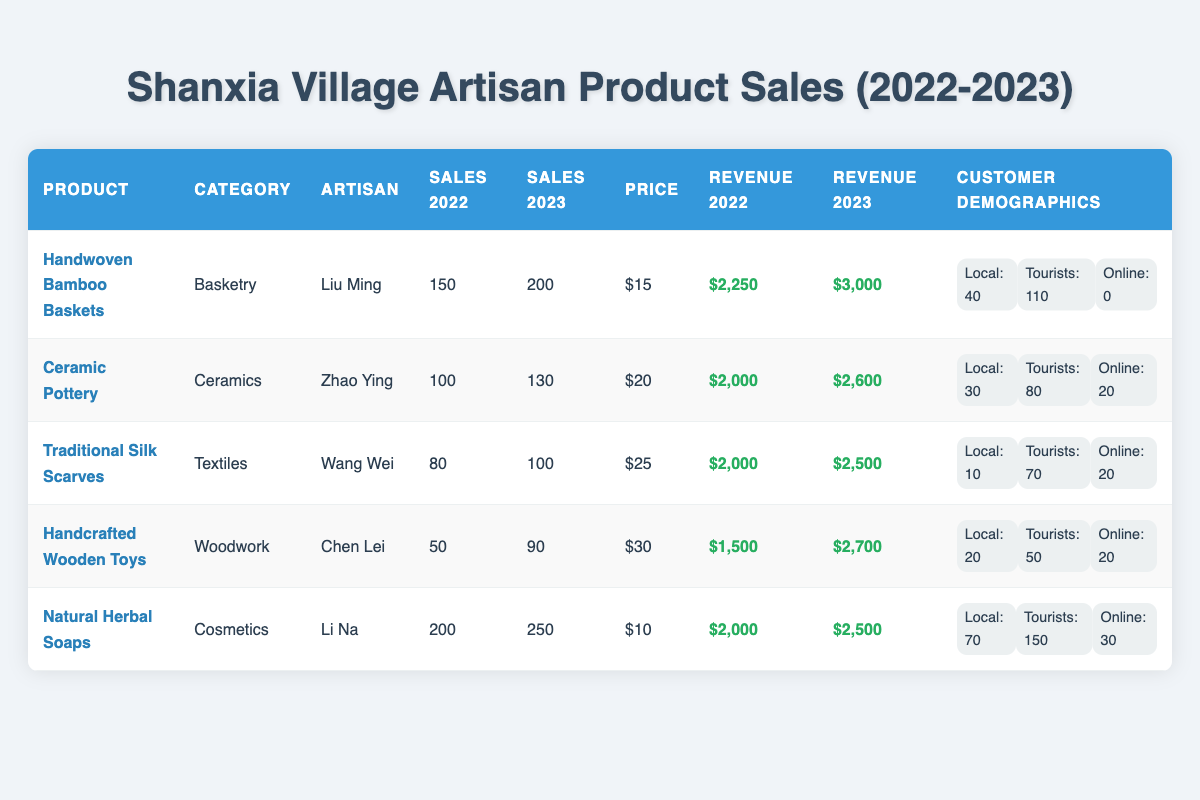What is the total sales number for Handwoven Bamboo Baskets in 2023? The table shows that Handwoven Bamboo Baskets had sales of 200 units in 2023.
Answer: 200 What was the price per unit for Traditional Silk Scarves? The price per unit for Traditional Silk Scarves is listed as $25 in the table.
Answer: $25 Which artisan had the highest total revenue in 2023? The total revenue for each artisan in 2023 is: Handwoven Bamboo Baskets - $3,000; Ceramic Pottery - $2,600; Traditional Silk Scarves - $2,500; Handcrafted Wooden Toys - $2,700; Natural Herbal Soaps - $2,500. Handwoven Bamboo Baskets had the highest at $3,000.
Answer: Handwoven Bamboo Baskets Did sales for Natural Herbal Soaps increase from 2022 to 2023? The sales number for Natural Herbal Soaps in 2022 was 200, and in 2023 it increased to 250, indicating an increase.
Answer: Yes What is the total revenue from online sales for Ceramic Pottery and Traditional Silk Scarves combined? The total online sales for Ceramic Pottery is 20 and for Traditional Silk Scarves is also 20. Therefore, the total online sales revenue is 20 + 20 = 40. Each unit is $20 for Ceramic Pottery and $25 for Traditional Silk Scarves, so total revenue is (20 × $20) + (20 × $25) = $400 + $500 = $900.
Answer: $900 Which product's sales increased by the largest percentage from 2022 to 2023? To find the percentage increase, use the formula: ((Sales in 2023 - Sales in 2022) / Sales in 2022) × 100. Calculating for all products: Handwoven Bamboo Baskets: ((200 - 150) / 150) × 100 = 33.33%; Ceramic Pottery: ((130 - 100) / 100) × 100 = 30%; Traditional Silk Scarves: ((100 - 80) / 80) × 100 = 25%; Handcrafted Wooden Toys: ((90 - 50) / 50) × 100 = 80%; Natural Herbal Soaps: ((250 - 200) / 200) × 100 = 25%. Handcrafted Wooden Toys had the largest increase at 80%.
Answer: Handcrafted Wooden Toys What percentage of total customers for Natural Herbal Soaps were tourists in 2023? The total number of customers for Natural Herbal Soaps in 2023 was 250 (70 locals + 150 tourists + 30 online). The number of tourists was 150. The percentage of tourists is (150 / 250) × 100 = 60%.
Answer: 60% Which artisan had local customers for their product, and how many were there? The local customers for each artisan's product are as follows: Liu Ming for Handwoven Bamboo Baskets had 40, Zhao Ying for Ceramic Pottery had 30, Wang Wei for Traditional Silk Scarves had 10, Chen Lei for Handcrafted Wooden Toys had 20, and Li Na for Natural Herbal Soaps had 70. All artisans had local customers.
Answer: Yes What is the average sales figure for all products in 2022? The sales figures for 2022 are: 150 + 100 + 80 + 50 + 200 = 580. To find the average, divide by the number of products, which is 5: 580 / 5 = 116.
Answer: 116 How many products had more tourist customers than local customers in 2023? By inspecting the 2023 customer demographics, for Handwoven Bamboo Baskets (110 tourists, 40 locals), Ceramic Pottery (80 tourists, 30 locals), Traditional Silk Scarves (70 tourists, 10 locals), Handcrafted Wooden Toys (50 tourists, 20 locals), and Natural Herbal Soaps (150 tourists, 70 locals) - all products had more tourists than locals. Thus, there are 5 products.
Answer: 5 